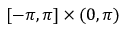<formula> <loc_0><loc_0><loc_500><loc_500>[ - \pi , \pi ] \times ( 0 , \pi )</formula> 